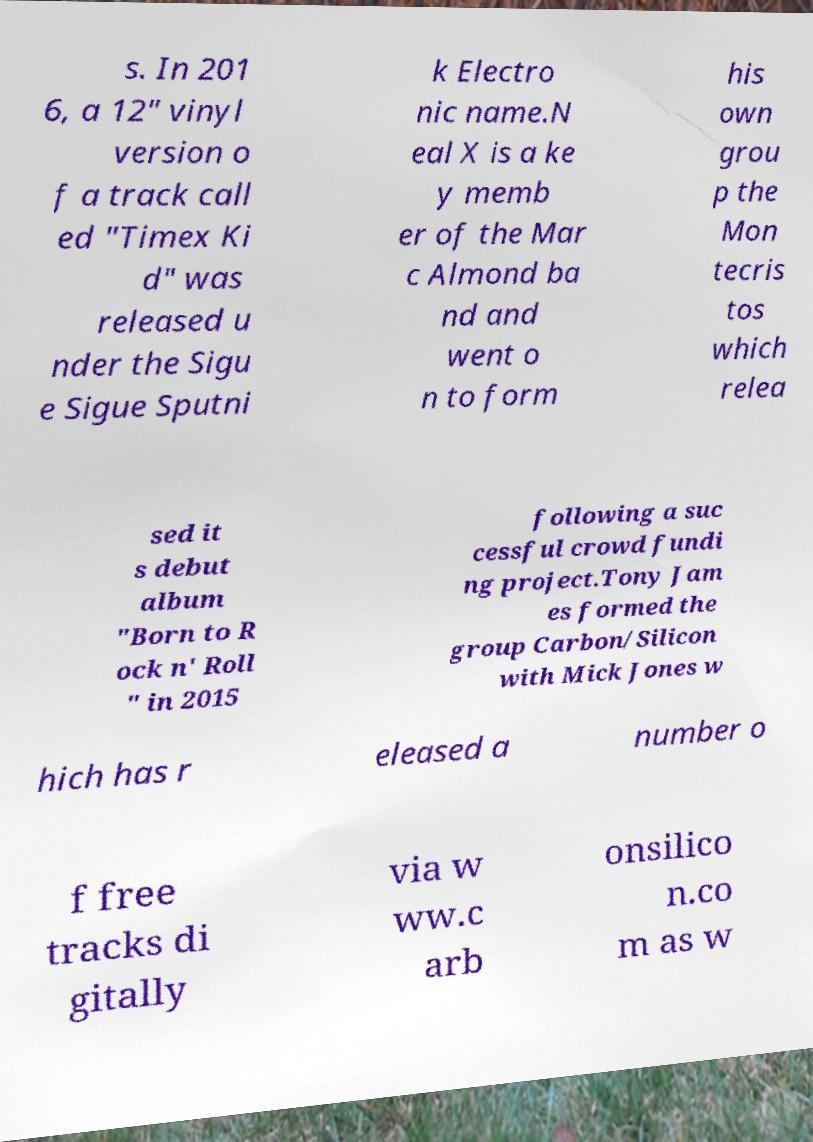I need the written content from this picture converted into text. Can you do that? s. In 201 6, a 12" vinyl version o f a track call ed "Timex Ki d" was released u nder the Sigu e Sigue Sputni k Electro nic name.N eal X is a ke y memb er of the Mar c Almond ba nd and went o n to form his own grou p the Mon tecris tos which relea sed it s debut album "Born to R ock n' Roll " in 2015 following a suc cessful crowd fundi ng project.Tony Jam es formed the group Carbon/Silicon with Mick Jones w hich has r eleased a number o f free tracks di gitally via w ww.c arb onsilico n.co m as w 